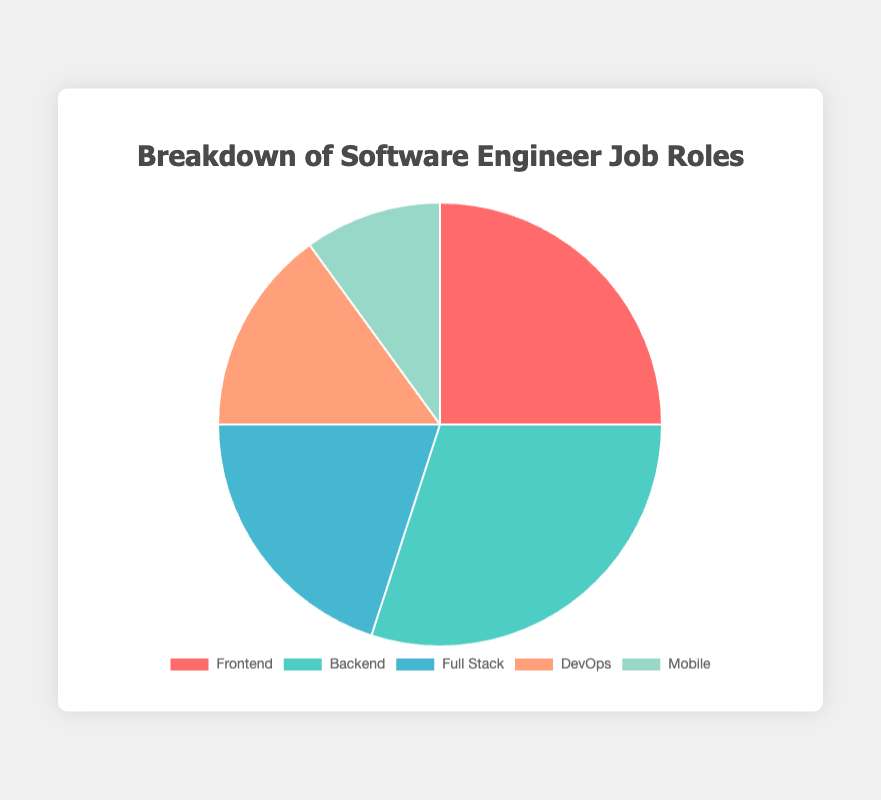What is the most common job role among software engineers in the figure? The slice representing Backend is the largest, indicating that Backend is the most common job role.
Answer: Backend Which job role has the smallest percentage? The smallest slice in the pie chart represents the Mobile job role.
Answer: Mobile How does the percentage of Full Stack engineers compare to DevOps engineers? Full Stack engineers constitute 20%, while DevOps engineers make up 15%. Therefore, Full Stack engineers have a higher percentage than DevOps engineers by 5%.
Answer: Full Stack engineers have 5% more What is the total percentage of engineers working in Backend and Frontend roles combined? The Backend role is 30%, and the Frontend role is 25%. Adding these percentages gives 30% + 25% = 55%.
Answer: 55% Is the percentage of Mobile engineers less than half of the Full Stack engineers? Full Stack engineers make up 20%, and Mobile engineers make up 10%. Since 10% is half of 20%, the percentage of Mobile engineers is exactly half of the Full Stack engineers, not less.
Answer: No What percentage of engineers are not involved in Frontend roles? The Frontend role is 25%. Subtracting this from 100% gives 100% - 25% = 75%.
Answer: 75% Which two job roles combined make up exactly 50% of the total? Combining the Frontend role (25%) and the Full Stack role (20%) equals 45%. Combining the Full Stack role (20%) and DevOps role (15%) equals 35%. The correct combination is the Backend role (30%) and DevOps role (15%), totaling 30% + 20% = 50%.
Answer: Backend and Full Stack Which job role is represented in red? The color coding in the pie chart shows that the Frontend role is represented in red.
Answer: Frontend What is the percentage difference between the largest and smallest job roles? The largest job role, Backend, is 30%, and the smallest, Mobile, is 10%. The difference is 30% - 10% = 20%.
Answer: 20% What is the average percentage value for all job roles? Summing up the percentages (25% + 30% + 20% + 15% + 10%) gives 100%. There are 5 job roles, so the average is 100% / 5 = 20%.
Answer: 20% 